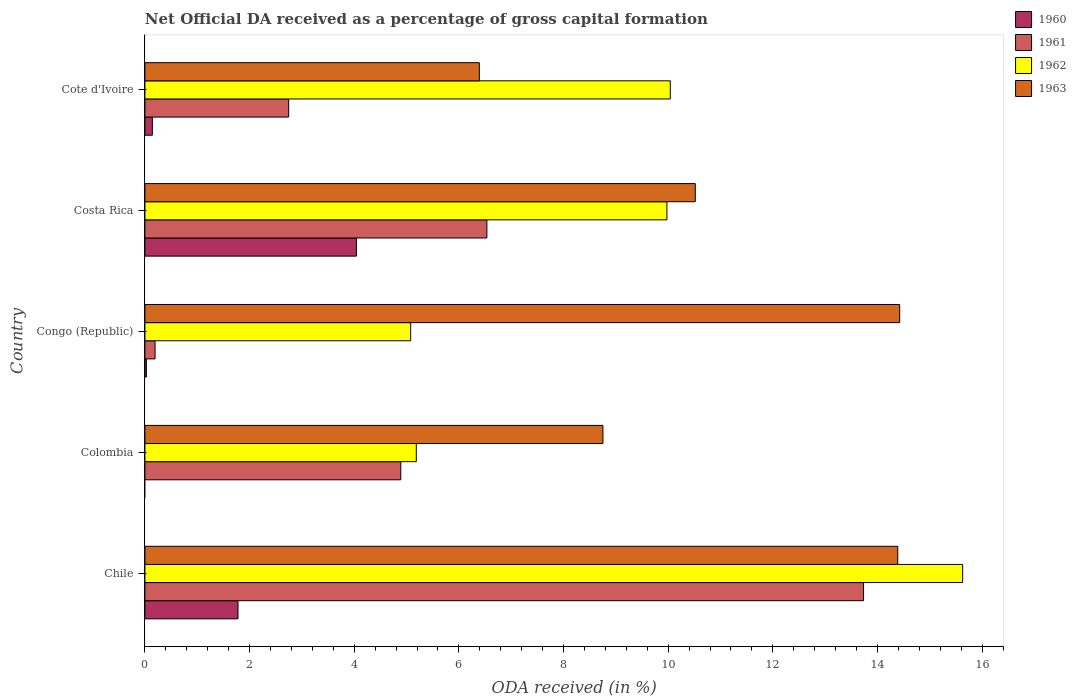How many different coloured bars are there?
Offer a terse response. 4. How many groups of bars are there?
Make the answer very short. 5. Are the number of bars per tick equal to the number of legend labels?
Provide a succinct answer. No. Are the number of bars on each tick of the Y-axis equal?
Offer a very short reply. No. How many bars are there on the 1st tick from the top?
Ensure brevity in your answer.  4. How many bars are there on the 1st tick from the bottom?
Make the answer very short. 4. What is the net ODA received in 1962 in Colombia?
Offer a very short reply. 5.19. Across all countries, what is the maximum net ODA received in 1960?
Provide a short and direct response. 4.04. Across all countries, what is the minimum net ODA received in 1962?
Your response must be concise. 5.08. In which country was the net ODA received in 1960 maximum?
Make the answer very short. Costa Rica. What is the total net ODA received in 1962 in the graph?
Ensure brevity in your answer.  45.91. What is the difference between the net ODA received in 1963 in Congo (Republic) and that in Costa Rica?
Keep it short and to the point. 3.91. What is the difference between the net ODA received in 1963 in Congo (Republic) and the net ODA received in 1960 in Cote d'Ivoire?
Provide a short and direct response. 14.28. What is the average net ODA received in 1960 per country?
Keep it short and to the point. 1.2. What is the difference between the net ODA received in 1962 and net ODA received in 1960 in Congo (Republic)?
Your answer should be compact. 5.05. In how many countries, is the net ODA received in 1961 greater than 2.4 %?
Ensure brevity in your answer.  4. What is the ratio of the net ODA received in 1962 in Chile to that in Colombia?
Your response must be concise. 3.01. What is the difference between the highest and the second highest net ODA received in 1963?
Your answer should be very brief. 0.04. What is the difference between the highest and the lowest net ODA received in 1963?
Your response must be concise. 8.03. Is the sum of the net ODA received in 1963 in Chile and Cote d'Ivoire greater than the maximum net ODA received in 1961 across all countries?
Provide a short and direct response. Yes. Is it the case that in every country, the sum of the net ODA received in 1963 and net ODA received in 1961 is greater than the net ODA received in 1962?
Make the answer very short. No. How many countries are there in the graph?
Ensure brevity in your answer.  5. What is the difference between two consecutive major ticks on the X-axis?
Offer a very short reply. 2. Are the values on the major ticks of X-axis written in scientific E-notation?
Keep it short and to the point. No. Does the graph contain any zero values?
Offer a very short reply. Yes. Does the graph contain grids?
Your response must be concise. No. Where does the legend appear in the graph?
Make the answer very short. Top right. How many legend labels are there?
Your response must be concise. 4. How are the legend labels stacked?
Your answer should be compact. Vertical. What is the title of the graph?
Give a very brief answer. Net Official DA received as a percentage of gross capital formation. What is the label or title of the X-axis?
Your answer should be compact. ODA received (in %). What is the label or title of the Y-axis?
Your answer should be compact. Country. What is the ODA received (in %) in 1960 in Chile?
Provide a short and direct response. 1.78. What is the ODA received (in %) in 1961 in Chile?
Your answer should be compact. 13.73. What is the ODA received (in %) in 1962 in Chile?
Provide a short and direct response. 15.63. What is the ODA received (in %) in 1963 in Chile?
Give a very brief answer. 14.39. What is the ODA received (in %) of 1961 in Colombia?
Keep it short and to the point. 4.89. What is the ODA received (in %) of 1962 in Colombia?
Keep it short and to the point. 5.19. What is the ODA received (in %) in 1963 in Colombia?
Keep it short and to the point. 8.75. What is the ODA received (in %) in 1960 in Congo (Republic)?
Offer a terse response. 0.03. What is the ODA received (in %) in 1961 in Congo (Republic)?
Your response must be concise. 0.19. What is the ODA received (in %) in 1962 in Congo (Republic)?
Offer a terse response. 5.08. What is the ODA received (in %) in 1963 in Congo (Republic)?
Your answer should be very brief. 14.43. What is the ODA received (in %) in 1960 in Costa Rica?
Ensure brevity in your answer.  4.04. What is the ODA received (in %) of 1961 in Costa Rica?
Make the answer very short. 6.54. What is the ODA received (in %) in 1962 in Costa Rica?
Keep it short and to the point. 9.98. What is the ODA received (in %) in 1963 in Costa Rica?
Offer a terse response. 10.52. What is the ODA received (in %) in 1960 in Cote d'Ivoire?
Ensure brevity in your answer.  0.14. What is the ODA received (in %) of 1961 in Cote d'Ivoire?
Offer a terse response. 2.75. What is the ODA received (in %) of 1962 in Cote d'Ivoire?
Provide a succinct answer. 10.04. What is the ODA received (in %) in 1963 in Cote d'Ivoire?
Provide a short and direct response. 6.39. Across all countries, what is the maximum ODA received (in %) of 1960?
Your answer should be compact. 4.04. Across all countries, what is the maximum ODA received (in %) of 1961?
Give a very brief answer. 13.73. Across all countries, what is the maximum ODA received (in %) of 1962?
Your answer should be compact. 15.63. Across all countries, what is the maximum ODA received (in %) of 1963?
Keep it short and to the point. 14.43. Across all countries, what is the minimum ODA received (in %) in 1961?
Your response must be concise. 0.19. Across all countries, what is the minimum ODA received (in %) in 1962?
Offer a terse response. 5.08. Across all countries, what is the minimum ODA received (in %) in 1963?
Your answer should be very brief. 6.39. What is the total ODA received (in %) in 1960 in the graph?
Your answer should be compact. 5.99. What is the total ODA received (in %) in 1961 in the graph?
Provide a succinct answer. 28.1. What is the total ODA received (in %) in 1962 in the graph?
Provide a succinct answer. 45.91. What is the total ODA received (in %) in 1963 in the graph?
Ensure brevity in your answer.  54.48. What is the difference between the ODA received (in %) in 1961 in Chile and that in Colombia?
Keep it short and to the point. 8.84. What is the difference between the ODA received (in %) of 1962 in Chile and that in Colombia?
Provide a short and direct response. 10.44. What is the difference between the ODA received (in %) in 1963 in Chile and that in Colombia?
Offer a terse response. 5.63. What is the difference between the ODA received (in %) of 1960 in Chile and that in Congo (Republic)?
Offer a terse response. 1.75. What is the difference between the ODA received (in %) in 1961 in Chile and that in Congo (Republic)?
Ensure brevity in your answer.  13.54. What is the difference between the ODA received (in %) in 1962 in Chile and that in Congo (Republic)?
Your answer should be very brief. 10.55. What is the difference between the ODA received (in %) of 1963 in Chile and that in Congo (Republic)?
Give a very brief answer. -0.04. What is the difference between the ODA received (in %) in 1960 in Chile and that in Costa Rica?
Provide a succinct answer. -2.26. What is the difference between the ODA received (in %) of 1961 in Chile and that in Costa Rica?
Your answer should be very brief. 7.2. What is the difference between the ODA received (in %) of 1962 in Chile and that in Costa Rica?
Provide a succinct answer. 5.65. What is the difference between the ODA received (in %) in 1963 in Chile and that in Costa Rica?
Your response must be concise. 3.87. What is the difference between the ODA received (in %) in 1960 in Chile and that in Cote d'Ivoire?
Provide a short and direct response. 1.64. What is the difference between the ODA received (in %) in 1961 in Chile and that in Cote d'Ivoire?
Offer a very short reply. 10.99. What is the difference between the ODA received (in %) of 1962 in Chile and that in Cote d'Ivoire?
Offer a terse response. 5.59. What is the difference between the ODA received (in %) of 1963 in Chile and that in Cote d'Ivoire?
Keep it short and to the point. 8. What is the difference between the ODA received (in %) in 1961 in Colombia and that in Congo (Republic)?
Give a very brief answer. 4.7. What is the difference between the ODA received (in %) in 1962 in Colombia and that in Congo (Republic)?
Provide a succinct answer. 0.11. What is the difference between the ODA received (in %) in 1963 in Colombia and that in Congo (Republic)?
Provide a short and direct response. -5.67. What is the difference between the ODA received (in %) of 1961 in Colombia and that in Costa Rica?
Offer a very short reply. -1.65. What is the difference between the ODA received (in %) of 1962 in Colombia and that in Costa Rica?
Keep it short and to the point. -4.79. What is the difference between the ODA received (in %) of 1963 in Colombia and that in Costa Rica?
Ensure brevity in your answer.  -1.76. What is the difference between the ODA received (in %) in 1961 in Colombia and that in Cote d'Ivoire?
Your answer should be compact. 2.14. What is the difference between the ODA received (in %) in 1962 in Colombia and that in Cote d'Ivoire?
Your response must be concise. -4.86. What is the difference between the ODA received (in %) of 1963 in Colombia and that in Cote d'Ivoire?
Provide a succinct answer. 2.36. What is the difference between the ODA received (in %) in 1960 in Congo (Republic) and that in Costa Rica?
Your response must be concise. -4.01. What is the difference between the ODA received (in %) in 1961 in Congo (Republic) and that in Costa Rica?
Keep it short and to the point. -6.34. What is the difference between the ODA received (in %) in 1962 in Congo (Republic) and that in Costa Rica?
Your answer should be very brief. -4.9. What is the difference between the ODA received (in %) in 1963 in Congo (Republic) and that in Costa Rica?
Provide a succinct answer. 3.91. What is the difference between the ODA received (in %) in 1960 in Congo (Republic) and that in Cote d'Ivoire?
Provide a short and direct response. -0.11. What is the difference between the ODA received (in %) of 1961 in Congo (Republic) and that in Cote d'Ivoire?
Provide a short and direct response. -2.55. What is the difference between the ODA received (in %) in 1962 in Congo (Republic) and that in Cote d'Ivoire?
Ensure brevity in your answer.  -4.96. What is the difference between the ODA received (in %) of 1963 in Congo (Republic) and that in Cote d'Ivoire?
Provide a succinct answer. 8.03. What is the difference between the ODA received (in %) in 1960 in Costa Rica and that in Cote d'Ivoire?
Make the answer very short. 3.9. What is the difference between the ODA received (in %) in 1961 in Costa Rica and that in Cote d'Ivoire?
Make the answer very short. 3.79. What is the difference between the ODA received (in %) in 1962 in Costa Rica and that in Cote d'Ivoire?
Keep it short and to the point. -0.06. What is the difference between the ODA received (in %) of 1963 in Costa Rica and that in Cote d'Ivoire?
Ensure brevity in your answer.  4.13. What is the difference between the ODA received (in %) of 1960 in Chile and the ODA received (in %) of 1961 in Colombia?
Your answer should be very brief. -3.11. What is the difference between the ODA received (in %) in 1960 in Chile and the ODA received (in %) in 1962 in Colombia?
Your answer should be very brief. -3.41. What is the difference between the ODA received (in %) of 1960 in Chile and the ODA received (in %) of 1963 in Colombia?
Your answer should be very brief. -6.97. What is the difference between the ODA received (in %) of 1961 in Chile and the ODA received (in %) of 1962 in Colombia?
Offer a very short reply. 8.55. What is the difference between the ODA received (in %) in 1961 in Chile and the ODA received (in %) in 1963 in Colombia?
Ensure brevity in your answer.  4.98. What is the difference between the ODA received (in %) of 1962 in Chile and the ODA received (in %) of 1963 in Colombia?
Give a very brief answer. 6.88. What is the difference between the ODA received (in %) in 1960 in Chile and the ODA received (in %) in 1961 in Congo (Republic)?
Offer a terse response. 1.59. What is the difference between the ODA received (in %) of 1960 in Chile and the ODA received (in %) of 1962 in Congo (Republic)?
Provide a succinct answer. -3.3. What is the difference between the ODA received (in %) of 1960 in Chile and the ODA received (in %) of 1963 in Congo (Republic)?
Offer a terse response. -12.65. What is the difference between the ODA received (in %) in 1961 in Chile and the ODA received (in %) in 1962 in Congo (Republic)?
Your response must be concise. 8.66. What is the difference between the ODA received (in %) in 1961 in Chile and the ODA received (in %) in 1963 in Congo (Republic)?
Give a very brief answer. -0.69. What is the difference between the ODA received (in %) of 1962 in Chile and the ODA received (in %) of 1963 in Congo (Republic)?
Offer a terse response. 1.2. What is the difference between the ODA received (in %) of 1960 in Chile and the ODA received (in %) of 1961 in Costa Rica?
Keep it short and to the point. -4.76. What is the difference between the ODA received (in %) of 1960 in Chile and the ODA received (in %) of 1962 in Costa Rica?
Make the answer very short. -8.2. What is the difference between the ODA received (in %) in 1960 in Chile and the ODA received (in %) in 1963 in Costa Rica?
Give a very brief answer. -8.74. What is the difference between the ODA received (in %) of 1961 in Chile and the ODA received (in %) of 1962 in Costa Rica?
Keep it short and to the point. 3.76. What is the difference between the ODA received (in %) in 1961 in Chile and the ODA received (in %) in 1963 in Costa Rica?
Your answer should be compact. 3.22. What is the difference between the ODA received (in %) in 1962 in Chile and the ODA received (in %) in 1963 in Costa Rica?
Offer a very short reply. 5.11. What is the difference between the ODA received (in %) in 1960 in Chile and the ODA received (in %) in 1961 in Cote d'Ivoire?
Provide a succinct answer. -0.97. What is the difference between the ODA received (in %) of 1960 in Chile and the ODA received (in %) of 1962 in Cote d'Ivoire?
Give a very brief answer. -8.26. What is the difference between the ODA received (in %) in 1960 in Chile and the ODA received (in %) in 1963 in Cote d'Ivoire?
Keep it short and to the point. -4.61. What is the difference between the ODA received (in %) of 1961 in Chile and the ODA received (in %) of 1962 in Cote d'Ivoire?
Provide a succinct answer. 3.69. What is the difference between the ODA received (in %) of 1961 in Chile and the ODA received (in %) of 1963 in Cote d'Ivoire?
Your response must be concise. 7.34. What is the difference between the ODA received (in %) in 1962 in Chile and the ODA received (in %) in 1963 in Cote d'Ivoire?
Your answer should be compact. 9.24. What is the difference between the ODA received (in %) in 1961 in Colombia and the ODA received (in %) in 1962 in Congo (Republic)?
Your answer should be very brief. -0.19. What is the difference between the ODA received (in %) of 1961 in Colombia and the ODA received (in %) of 1963 in Congo (Republic)?
Keep it short and to the point. -9.54. What is the difference between the ODA received (in %) of 1962 in Colombia and the ODA received (in %) of 1963 in Congo (Republic)?
Your answer should be compact. -9.24. What is the difference between the ODA received (in %) in 1961 in Colombia and the ODA received (in %) in 1962 in Costa Rica?
Give a very brief answer. -5.09. What is the difference between the ODA received (in %) of 1961 in Colombia and the ODA received (in %) of 1963 in Costa Rica?
Offer a very short reply. -5.63. What is the difference between the ODA received (in %) in 1962 in Colombia and the ODA received (in %) in 1963 in Costa Rica?
Your answer should be very brief. -5.33. What is the difference between the ODA received (in %) in 1961 in Colombia and the ODA received (in %) in 1962 in Cote d'Ivoire?
Offer a very short reply. -5.15. What is the difference between the ODA received (in %) of 1961 in Colombia and the ODA received (in %) of 1963 in Cote d'Ivoire?
Offer a terse response. -1.5. What is the difference between the ODA received (in %) in 1962 in Colombia and the ODA received (in %) in 1963 in Cote d'Ivoire?
Your response must be concise. -1.2. What is the difference between the ODA received (in %) of 1960 in Congo (Republic) and the ODA received (in %) of 1961 in Costa Rica?
Your answer should be very brief. -6.51. What is the difference between the ODA received (in %) in 1960 in Congo (Republic) and the ODA received (in %) in 1962 in Costa Rica?
Provide a succinct answer. -9.95. What is the difference between the ODA received (in %) of 1960 in Congo (Republic) and the ODA received (in %) of 1963 in Costa Rica?
Your response must be concise. -10.49. What is the difference between the ODA received (in %) in 1961 in Congo (Republic) and the ODA received (in %) in 1962 in Costa Rica?
Provide a succinct answer. -9.78. What is the difference between the ODA received (in %) in 1961 in Congo (Republic) and the ODA received (in %) in 1963 in Costa Rica?
Your response must be concise. -10.32. What is the difference between the ODA received (in %) of 1962 in Congo (Republic) and the ODA received (in %) of 1963 in Costa Rica?
Ensure brevity in your answer.  -5.44. What is the difference between the ODA received (in %) of 1960 in Congo (Republic) and the ODA received (in %) of 1961 in Cote d'Ivoire?
Your answer should be very brief. -2.72. What is the difference between the ODA received (in %) of 1960 in Congo (Republic) and the ODA received (in %) of 1962 in Cote d'Ivoire?
Your answer should be very brief. -10.01. What is the difference between the ODA received (in %) of 1960 in Congo (Republic) and the ODA received (in %) of 1963 in Cote d'Ivoire?
Your answer should be compact. -6.36. What is the difference between the ODA received (in %) of 1961 in Congo (Republic) and the ODA received (in %) of 1962 in Cote d'Ivoire?
Ensure brevity in your answer.  -9.85. What is the difference between the ODA received (in %) of 1961 in Congo (Republic) and the ODA received (in %) of 1963 in Cote d'Ivoire?
Provide a short and direct response. -6.2. What is the difference between the ODA received (in %) of 1962 in Congo (Republic) and the ODA received (in %) of 1963 in Cote d'Ivoire?
Your answer should be compact. -1.31. What is the difference between the ODA received (in %) in 1960 in Costa Rica and the ODA received (in %) in 1961 in Cote d'Ivoire?
Provide a succinct answer. 1.29. What is the difference between the ODA received (in %) of 1960 in Costa Rica and the ODA received (in %) of 1962 in Cote d'Ivoire?
Provide a succinct answer. -6. What is the difference between the ODA received (in %) of 1960 in Costa Rica and the ODA received (in %) of 1963 in Cote d'Ivoire?
Offer a very short reply. -2.35. What is the difference between the ODA received (in %) in 1961 in Costa Rica and the ODA received (in %) in 1962 in Cote d'Ivoire?
Ensure brevity in your answer.  -3.51. What is the difference between the ODA received (in %) of 1961 in Costa Rica and the ODA received (in %) of 1963 in Cote d'Ivoire?
Keep it short and to the point. 0.14. What is the difference between the ODA received (in %) of 1962 in Costa Rica and the ODA received (in %) of 1963 in Cote d'Ivoire?
Provide a short and direct response. 3.59. What is the average ODA received (in %) of 1960 per country?
Offer a terse response. 1.2. What is the average ODA received (in %) in 1961 per country?
Offer a terse response. 5.62. What is the average ODA received (in %) of 1962 per country?
Provide a short and direct response. 9.18. What is the average ODA received (in %) of 1963 per country?
Your answer should be very brief. 10.9. What is the difference between the ODA received (in %) of 1960 and ODA received (in %) of 1961 in Chile?
Ensure brevity in your answer.  -11.96. What is the difference between the ODA received (in %) of 1960 and ODA received (in %) of 1962 in Chile?
Your response must be concise. -13.85. What is the difference between the ODA received (in %) of 1960 and ODA received (in %) of 1963 in Chile?
Keep it short and to the point. -12.61. What is the difference between the ODA received (in %) of 1961 and ODA received (in %) of 1962 in Chile?
Provide a succinct answer. -1.89. What is the difference between the ODA received (in %) of 1961 and ODA received (in %) of 1963 in Chile?
Give a very brief answer. -0.65. What is the difference between the ODA received (in %) of 1962 and ODA received (in %) of 1963 in Chile?
Your answer should be very brief. 1.24. What is the difference between the ODA received (in %) in 1961 and ODA received (in %) in 1962 in Colombia?
Keep it short and to the point. -0.3. What is the difference between the ODA received (in %) of 1961 and ODA received (in %) of 1963 in Colombia?
Provide a succinct answer. -3.86. What is the difference between the ODA received (in %) in 1962 and ODA received (in %) in 1963 in Colombia?
Provide a short and direct response. -3.57. What is the difference between the ODA received (in %) in 1960 and ODA received (in %) in 1961 in Congo (Republic)?
Your answer should be compact. -0.17. What is the difference between the ODA received (in %) of 1960 and ODA received (in %) of 1962 in Congo (Republic)?
Provide a succinct answer. -5.05. What is the difference between the ODA received (in %) of 1960 and ODA received (in %) of 1963 in Congo (Republic)?
Provide a succinct answer. -14.4. What is the difference between the ODA received (in %) of 1961 and ODA received (in %) of 1962 in Congo (Republic)?
Make the answer very short. -4.89. What is the difference between the ODA received (in %) of 1961 and ODA received (in %) of 1963 in Congo (Republic)?
Your answer should be very brief. -14.23. What is the difference between the ODA received (in %) of 1962 and ODA received (in %) of 1963 in Congo (Republic)?
Offer a terse response. -9.35. What is the difference between the ODA received (in %) in 1960 and ODA received (in %) in 1961 in Costa Rica?
Offer a very short reply. -2.49. What is the difference between the ODA received (in %) of 1960 and ODA received (in %) of 1962 in Costa Rica?
Offer a terse response. -5.93. What is the difference between the ODA received (in %) of 1960 and ODA received (in %) of 1963 in Costa Rica?
Make the answer very short. -6.48. What is the difference between the ODA received (in %) of 1961 and ODA received (in %) of 1962 in Costa Rica?
Ensure brevity in your answer.  -3.44. What is the difference between the ODA received (in %) in 1961 and ODA received (in %) in 1963 in Costa Rica?
Make the answer very short. -3.98. What is the difference between the ODA received (in %) in 1962 and ODA received (in %) in 1963 in Costa Rica?
Your answer should be compact. -0.54. What is the difference between the ODA received (in %) in 1960 and ODA received (in %) in 1961 in Cote d'Ivoire?
Provide a succinct answer. -2.6. What is the difference between the ODA received (in %) in 1960 and ODA received (in %) in 1962 in Cote d'Ivoire?
Make the answer very short. -9.9. What is the difference between the ODA received (in %) in 1960 and ODA received (in %) in 1963 in Cote d'Ivoire?
Provide a succinct answer. -6.25. What is the difference between the ODA received (in %) in 1961 and ODA received (in %) in 1962 in Cote d'Ivoire?
Your answer should be very brief. -7.29. What is the difference between the ODA received (in %) of 1961 and ODA received (in %) of 1963 in Cote d'Ivoire?
Offer a terse response. -3.64. What is the difference between the ODA received (in %) in 1962 and ODA received (in %) in 1963 in Cote d'Ivoire?
Offer a very short reply. 3.65. What is the ratio of the ODA received (in %) in 1961 in Chile to that in Colombia?
Provide a short and direct response. 2.81. What is the ratio of the ODA received (in %) in 1962 in Chile to that in Colombia?
Provide a short and direct response. 3.01. What is the ratio of the ODA received (in %) in 1963 in Chile to that in Colombia?
Your answer should be compact. 1.64. What is the ratio of the ODA received (in %) of 1960 in Chile to that in Congo (Republic)?
Your answer should be very brief. 62.32. What is the ratio of the ODA received (in %) in 1961 in Chile to that in Congo (Republic)?
Provide a short and direct response. 70.89. What is the ratio of the ODA received (in %) of 1962 in Chile to that in Congo (Republic)?
Make the answer very short. 3.08. What is the ratio of the ODA received (in %) in 1960 in Chile to that in Costa Rica?
Provide a short and direct response. 0.44. What is the ratio of the ODA received (in %) in 1961 in Chile to that in Costa Rica?
Offer a terse response. 2.1. What is the ratio of the ODA received (in %) in 1962 in Chile to that in Costa Rica?
Provide a succinct answer. 1.57. What is the ratio of the ODA received (in %) of 1963 in Chile to that in Costa Rica?
Offer a very short reply. 1.37. What is the ratio of the ODA received (in %) in 1960 in Chile to that in Cote d'Ivoire?
Ensure brevity in your answer.  12.5. What is the ratio of the ODA received (in %) of 1961 in Chile to that in Cote d'Ivoire?
Your answer should be very brief. 5. What is the ratio of the ODA received (in %) in 1962 in Chile to that in Cote d'Ivoire?
Your answer should be very brief. 1.56. What is the ratio of the ODA received (in %) in 1963 in Chile to that in Cote d'Ivoire?
Make the answer very short. 2.25. What is the ratio of the ODA received (in %) in 1961 in Colombia to that in Congo (Republic)?
Make the answer very short. 25.24. What is the ratio of the ODA received (in %) of 1962 in Colombia to that in Congo (Republic)?
Your answer should be compact. 1.02. What is the ratio of the ODA received (in %) in 1963 in Colombia to that in Congo (Republic)?
Ensure brevity in your answer.  0.61. What is the ratio of the ODA received (in %) in 1961 in Colombia to that in Costa Rica?
Offer a terse response. 0.75. What is the ratio of the ODA received (in %) in 1962 in Colombia to that in Costa Rica?
Your answer should be compact. 0.52. What is the ratio of the ODA received (in %) in 1963 in Colombia to that in Costa Rica?
Your answer should be very brief. 0.83. What is the ratio of the ODA received (in %) of 1961 in Colombia to that in Cote d'Ivoire?
Ensure brevity in your answer.  1.78. What is the ratio of the ODA received (in %) in 1962 in Colombia to that in Cote d'Ivoire?
Your answer should be very brief. 0.52. What is the ratio of the ODA received (in %) of 1963 in Colombia to that in Cote d'Ivoire?
Offer a very short reply. 1.37. What is the ratio of the ODA received (in %) in 1960 in Congo (Republic) to that in Costa Rica?
Offer a very short reply. 0.01. What is the ratio of the ODA received (in %) in 1961 in Congo (Republic) to that in Costa Rica?
Offer a very short reply. 0.03. What is the ratio of the ODA received (in %) of 1962 in Congo (Republic) to that in Costa Rica?
Offer a terse response. 0.51. What is the ratio of the ODA received (in %) of 1963 in Congo (Republic) to that in Costa Rica?
Provide a short and direct response. 1.37. What is the ratio of the ODA received (in %) of 1960 in Congo (Republic) to that in Cote d'Ivoire?
Give a very brief answer. 0.2. What is the ratio of the ODA received (in %) in 1961 in Congo (Republic) to that in Cote d'Ivoire?
Offer a terse response. 0.07. What is the ratio of the ODA received (in %) in 1962 in Congo (Republic) to that in Cote d'Ivoire?
Your answer should be compact. 0.51. What is the ratio of the ODA received (in %) in 1963 in Congo (Republic) to that in Cote d'Ivoire?
Offer a very short reply. 2.26. What is the ratio of the ODA received (in %) in 1960 in Costa Rica to that in Cote d'Ivoire?
Provide a short and direct response. 28.4. What is the ratio of the ODA received (in %) in 1961 in Costa Rica to that in Cote d'Ivoire?
Make the answer very short. 2.38. What is the ratio of the ODA received (in %) in 1963 in Costa Rica to that in Cote d'Ivoire?
Your answer should be compact. 1.65. What is the difference between the highest and the second highest ODA received (in %) in 1960?
Make the answer very short. 2.26. What is the difference between the highest and the second highest ODA received (in %) of 1961?
Your response must be concise. 7.2. What is the difference between the highest and the second highest ODA received (in %) of 1962?
Offer a very short reply. 5.59. What is the difference between the highest and the second highest ODA received (in %) in 1963?
Give a very brief answer. 0.04. What is the difference between the highest and the lowest ODA received (in %) of 1960?
Your answer should be compact. 4.04. What is the difference between the highest and the lowest ODA received (in %) of 1961?
Your answer should be compact. 13.54. What is the difference between the highest and the lowest ODA received (in %) of 1962?
Offer a very short reply. 10.55. What is the difference between the highest and the lowest ODA received (in %) of 1963?
Make the answer very short. 8.03. 